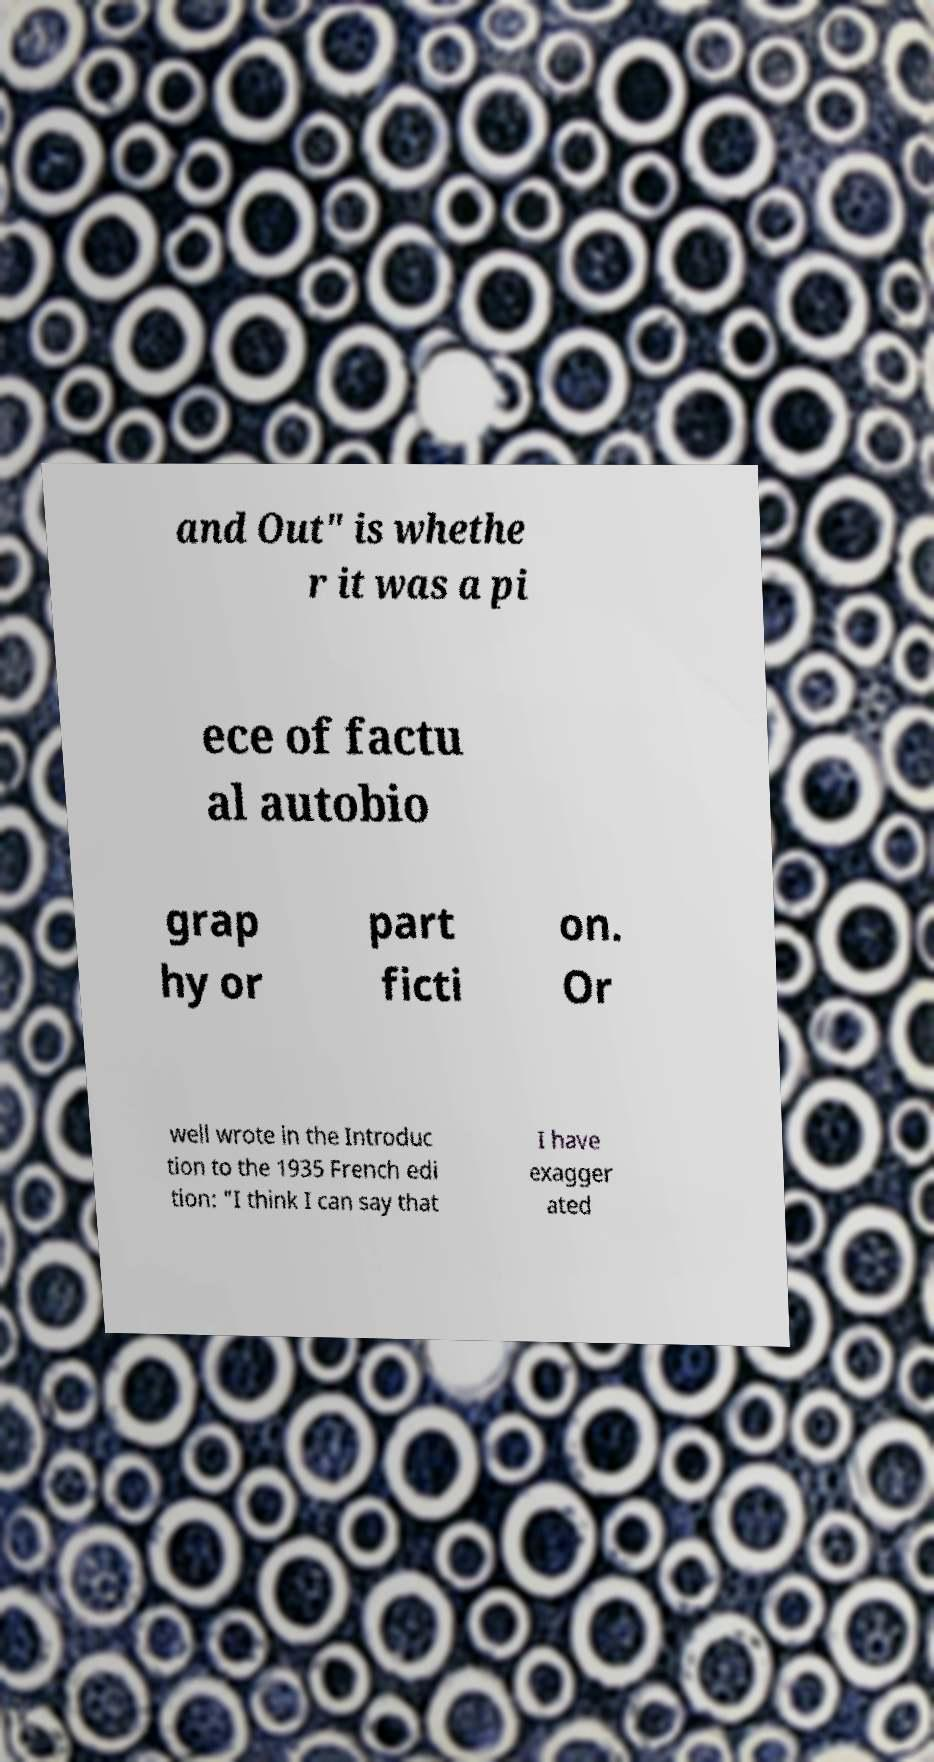Can you accurately transcribe the text from the provided image for me? and Out" is whethe r it was a pi ece of factu al autobio grap hy or part ficti on. Or well wrote in the Introduc tion to the 1935 French edi tion: "I think I can say that I have exagger ated 